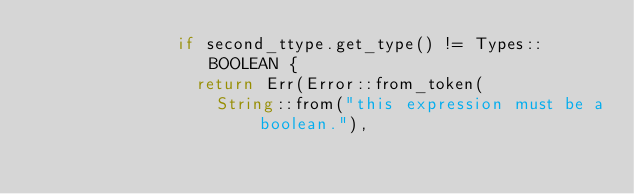<code> <loc_0><loc_0><loc_500><loc_500><_Rust_>              if second_ttype.get_type() != Types::BOOLEAN {
                return Err(Error::from_token(
                  String::from("this expression must be a boolean."),</code> 